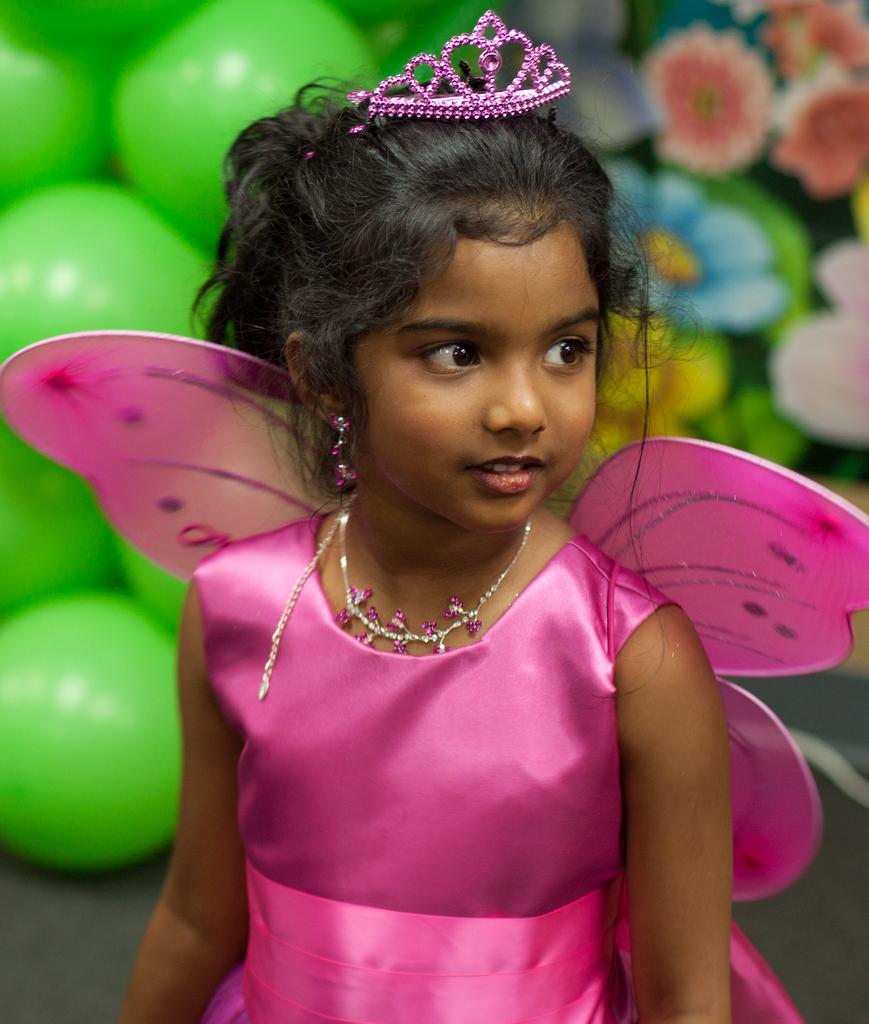What is the main subject of the image? There is a person standing in the image. What is on the person's head? The person has a tiara on her head. What can be seen in the background of the image? There are balls and objects that resemble flowers visible in the background of the image. How many brothers does the person in the image have? There is no information about the person's brothers in the image, so it cannot be determined. 